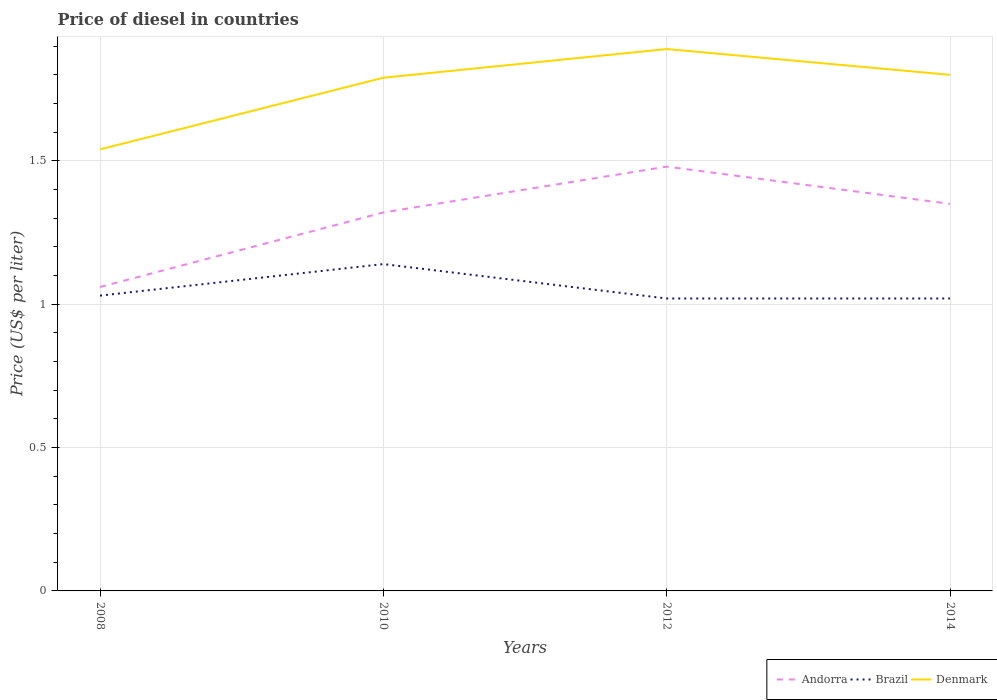How many different coloured lines are there?
Make the answer very short. 3. Does the line corresponding to Andorra intersect with the line corresponding to Brazil?
Provide a short and direct response. No. Across all years, what is the maximum price of diesel in Denmark?
Provide a short and direct response. 1.54. In which year was the price of diesel in Denmark maximum?
Provide a short and direct response. 2008. What is the total price of diesel in Andorra in the graph?
Your response must be concise. 0.13. What is the difference between the highest and the second highest price of diesel in Brazil?
Your answer should be compact. 0.12. What is the difference between the highest and the lowest price of diesel in Brazil?
Ensure brevity in your answer.  1. Is the price of diesel in Denmark strictly greater than the price of diesel in Andorra over the years?
Your response must be concise. No. What is the difference between two consecutive major ticks on the Y-axis?
Give a very brief answer. 0.5. Are the values on the major ticks of Y-axis written in scientific E-notation?
Provide a short and direct response. No. Does the graph contain any zero values?
Ensure brevity in your answer.  No. Where does the legend appear in the graph?
Provide a succinct answer. Bottom right. How many legend labels are there?
Your response must be concise. 3. How are the legend labels stacked?
Give a very brief answer. Horizontal. What is the title of the graph?
Your answer should be very brief. Price of diesel in countries. Does "St. Kitts and Nevis" appear as one of the legend labels in the graph?
Ensure brevity in your answer.  No. What is the label or title of the X-axis?
Provide a succinct answer. Years. What is the label or title of the Y-axis?
Your response must be concise. Price (US$ per liter). What is the Price (US$ per liter) in Andorra in 2008?
Keep it short and to the point. 1.06. What is the Price (US$ per liter) in Denmark in 2008?
Keep it short and to the point. 1.54. What is the Price (US$ per liter) of Andorra in 2010?
Your answer should be compact. 1.32. What is the Price (US$ per liter) of Brazil in 2010?
Offer a very short reply. 1.14. What is the Price (US$ per liter) of Denmark in 2010?
Provide a succinct answer. 1.79. What is the Price (US$ per liter) in Andorra in 2012?
Offer a terse response. 1.48. What is the Price (US$ per liter) in Brazil in 2012?
Your answer should be very brief. 1.02. What is the Price (US$ per liter) in Denmark in 2012?
Your response must be concise. 1.89. What is the Price (US$ per liter) in Andorra in 2014?
Give a very brief answer. 1.35. What is the Price (US$ per liter) of Brazil in 2014?
Offer a terse response. 1.02. What is the Price (US$ per liter) in Denmark in 2014?
Provide a succinct answer. 1.8. Across all years, what is the maximum Price (US$ per liter) in Andorra?
Offer a very short reply. 1.48. Across all years, what is the maximum Price (US$ per liter) in Brazil?
Offer a terse response. 1.14. Across all years, what is the maximum Price (US$ per liter) of Denmark?
Your answer should be compact. 1.89. Across all years, what is the minimum Price (US$ per liter) in Andorra?
Your answer should be compact. 1.06. Across all years, what is the minimum Price (US$ per liter) of Brazil?
Give a very brief answer. 1.02. Across all years, what is the minimum Price (US$ per liter) in Denmark?
Provide a short and direct response. 1.54. What is the total Price (US$ per liter) of Andorra in the graph?
Provide a succinct answer. 5.21. What is the total Price (US$ per liter) of Brazil in the graph?
Give a very brief answer. 4.21. What is the total Price (US$ per liter) of Denmark in the graph?
Offer a terse response. 7.02. What is the difference between the Price (US$ per liter) of Andorra in 2008 and that in 2010?
Offer a terse response. -0.26. What is the difference between the Price (US$ per liter) in Brazil in 2008 and that in 2010?
Offer a terse response. -0.11. What is the difference between the Price (US$ per liter) in Andorra in 2008 and that in 2012?
Keep it short and to the point. -0.42. What is the difference between the Price (US$ per liter) of Brazil in 2008 and that in 2012?
Offer a very short reply. 0.01. What is the difference between the Price (US$ per liter) in Denmark in 2008 and that in 2012?
Ensure brevity in your answer.  -0.35. What is the difference between the Price (US$ per liter) of Andorra in 2008 and that in 2014?
Your response must be concise. -0.29. What is the difference between the Price (US$ per liter) in Brazil in 2008 and that in 2014?
Make the answer very short. 0.01. What is the difference between the Price (US$ per liter) in Denmark in 2008 and that in 2014?
Offer a very short reply. -0.26. What is the difference between the Price (US$ per liter) in Andorra in 2010 and that in 2012?
Ensure brevity in your answer.  -0.16. What is the difference between the Price (US$ per liter) of Brazil in 2010 and that in 2012?
Your answer should be very brief. 0.12. What is the difference between the Price (US$ per liter) in Denmark in 2010 and that in 2012?
Keep it short and to the point. -0.1. What is the difference between the Price (US$ per liter) in Andorra in 2010 and that in 2014?
Offer a very short reply. -0.03. What is the difference between the Price (US$ per liter) of Brazil in 2010 and that in 2014?
Your response must be concise. 0.12. What is the difference between the Price (US$ per liter) in Denmark in 2010 and that in 2014?
Provide a succinct answer. -0.01. What is the difference between the Price (US$ per liter) of Andorra in 2012 and that in 2014?
Your answer should be very brief. 0.13. What is the difference between the Price (US$ per liter) of Brazil in 2012 and that in 2014?
Keep it short and to the point. 0. What is the difference between the Price (US$ per liter) of Denmark in 2012 and that in 2014?
Your answer should be very brief. 0.09. What is the difference between the Price (US$ per liter) in Andorra in 2008 and the Price (US$ per liter) in Brazil in 2010?
Your response must be concise. -0.08. What is the difference between the Price (US$ per liter) in Andorra in 2008 and the Price (US$ per liter) in Denmark in 2010?
Provide a short and direct response. -0.73. What is the difference between the Price (US$ per liter) of Brazil in 2008 and the Price (US$ per liter) of Denmark in 2010?
Your answer should be compact. -0.76. What is the difference between the Price (US$ per liter) in Andorra in 2008 and the Price (US$ per liter) in Denmark in 2012?
Offer a terse response. -0.83. What is the difference between the Price (US$ per liter) in Brazil in 2008 and the Price (US$ per liter) in Denmark in 2012?
Your response must be concise. -0.86. What is the difference between the Price (US$ per liter) in Andorra in 2008 and the Price (US$ per liter) in Denmark in 2014?
Keep it short and to the point. -0.74. What is the difference between the Price (US$ per liter) in Brazil in 2008 and the Price (US$ per liter) in Denmark in 2014?
Give a very brief answer. -0.77. What is the difference between the Price (US$ per liter) in Andorra in 2010 and the Price (US$ per liter) in Brazil in 2012?
Offer a terse response. 0.3. What is the difference between the Price (US$ per liter) in Andorra in 2010 and the Price (US$ per liter) in Denmark in 2012?
Give a very brief answer. -0.57. What is the difference between the Price (US$ per liter) in Brazil in 2010 and the Price (US$ per liter) in Denmark in 2012?
Your answer should be compact. -0.75. What is the difference between the Price (US$ per liter) of Andorra in 2010 and the Price (US$ per liter) of Denmark in 2014?
Give a very brief answer. -0.48. What is the difference between the Price (US$ per liter) in Brazil in 2010 and the Price (US$ per liter) in Denmark in 2014?
Your answer should be compact. -0.66. What is the difference between the Price (US$ per liter) in Andorra in 2012 and the Price (US$ per liter) in Brazil in 2014?
Give a very brief answer. 0.46. What is the difference between the Price (US$ per liter) in Andorra in 2012 and the Price (US$ per liter) in Denmark in 2014?
Ensure brevity in your answer.  -0.32. What is the difference between the Price (US$ per liter) of Brazil in 2012 and the Price (US$ per liter) of Denmark in 2014?
Offer a very short reply. -0.78. What is the average Price (US$ per liter) of Andorra per year?
Keep it short and to the point. 1.3. What is the average Price (US$ per liter) in Brazil per year?
Your response must be concise. 1.05. What is the average Price (US$ per liter) in Denmark per year?
Keep it short and to the point. 1.75. In the year 2008, what is the difference between the Price (US$ per liter) in Andorra and Price (US$ per liter) in Brazil?
Your response must be concise. 0.03. In the year 2008, what is the difference between the Price (US$ per liter) in Andorra and Price (US$ per liter) in Denmark?
Ensure brevity in your answer.  -0.48. In the year 2008, what is the difference between the Price (US$ per liter) of Brazil and Price (US$ per liter) of Denmark?
Give a very brief answer. -0.51. In the year 2010, what is the difference between the Price (US$ per liter) of Andorra and Price (US$ per liter) of Brazil?
Give a very brief answer. 0.18. In the year 2010, what is the difference between the Price (US$ per liter) of Andorra and Price (US$ per liter) of Denmark?
Your answer should be compact. -0.47. In the year 2010, what is the difference between the Price (US$ per liter) in Brazil and Price (US$ per liter) in Denmark?
Provide a short and direct response. -0.65. In the year 2012, what is the difference between the Price (US$ per liter) of Andorra and Price (US$ per liter) of Brazil?
Provide a short and direct response. 0.46. In the year 2012, what is the difference between the Price (US$ per liter) of Andorra and Price (US$ per liter) of Denmark?
Give a very brief answer. -0.41. In the year 2012, what is the difference between the Price (US$ per liter) in Brazil and Price (US$ per liter) in Denmark?
Give a very brief answer. -0.87. In the year 2014, what is the difference between the Price (US$ per liter) of Andorra and Price (US$ per liter) of Brazil?
Keep it short and to the point. 0.33. In the year 2014, what is the difference between the Price (US$ per liter) of Andorra and Price (US$ per liter) of Denmark?
Your answer should be very brief. -0.45. In the year 2014, what is the difference between the Price (US$ per liter) in Brazil and Price (US$ per liter) in Denmark?
Provide a short and direct response. -0.78. What is the ratio of the Price (US$ per liter) in Andorra in 2008 to that in 2010?
Make the answer very short. 0.8. What is the ratio of the Price (US$ per liter) in Brazil in 2008 to that in 2010?
Your answer should be compact. 0.9. What is the ratio of the Price (US$ per liter) in Denmark in 2008 to that in 2010?
Provide a succinct answer. 0.86. What is the ratio of the Price (US$ per liter) of Andorra in 2008 to that in 2012?
Keep it short and to the point. 0.72. What is the ratio of the Price (US$ per liter) in Brazil in 2008 to that in 2012?
Give a very brief answer. 1.01. What is the ratio of the Price (US$ per liter) of Denmark in 2008 to that in 2012?
Give a very brief answer. 0.81. What is the ratio of the Price (US$ per liter) in Andorra in 2008 to that in 2014?
Provide a short and direct response. 0.79. What is the ratio of the Price (US$ per liter) of Brazil in 2008 to that in 2014?
Give a very brief answer. 1.01. What is the ratio of the Price (US$ per liter) in Denmark in 2008 to that in 2014?
Your answer should be compact. 0.86. What is the ratio of the Price (US$ per liter) of Andorra in 2010 to that in 2012?
Provide a succinct answer. 0.89. What is the ratio of the Price (US$ per liter) in Brazil in 2010 to that in 2012?
Offer a very short reply. 1.12. What is the ratio of the Price (US$ per liter) of Denmark in 2010 to that in 2012?
Ensure brevity in your answer.  0.95. What is the ratio of the Price (US$ per liter) in Andorra in 2010 to that in 2014?
Your answer should be compact. 0.98. What is the ratio of the Price (US$ per liter) in Brazil in 2010 to that in 2014?
Ensure brevity in your answer.  1.12. What is the ratio of the Price (US$ per liter) in Andorra in 2012 to that in 2014?
Provide a succinct answer. 1.1. What is the ratio of the Price (US$ per liter) in Brazil in 2012 to that in 2014?
Your answer should be very brief. 1. What is the difference between the highest and the second highest Price (US$ per liter) of Andorra?
Provide a short and direct response. 0.13. What is the difference between the highest and the second highest Price (US$ per liter) of Brazil?
Your answer should be compact. 0.11. What is the difference between the highest and the second highest Price (US$ per liter) of Denmark?
Ensure brevity in your answer.  0.09. What is the difference between the highest and the lowest Price (US$ per liter) of Andorra?
Your answer should be very brief. 0.42. What is the difference between the highest and the lowest Price (US$ per liter) of Brazil?
Offer a very short reply. 0.12. What is the difference between the highest and the lowest Price (US$ per liter) of Denmark?
Keep it short and to the point. 0.35. 